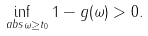<formula> <loc_0><loc_0><loc_500><loc_500>\inf _ { \ a b s { \omega } \geq t _ { 0 } } 1 - g ( \omega ) > 0 .</formula> 